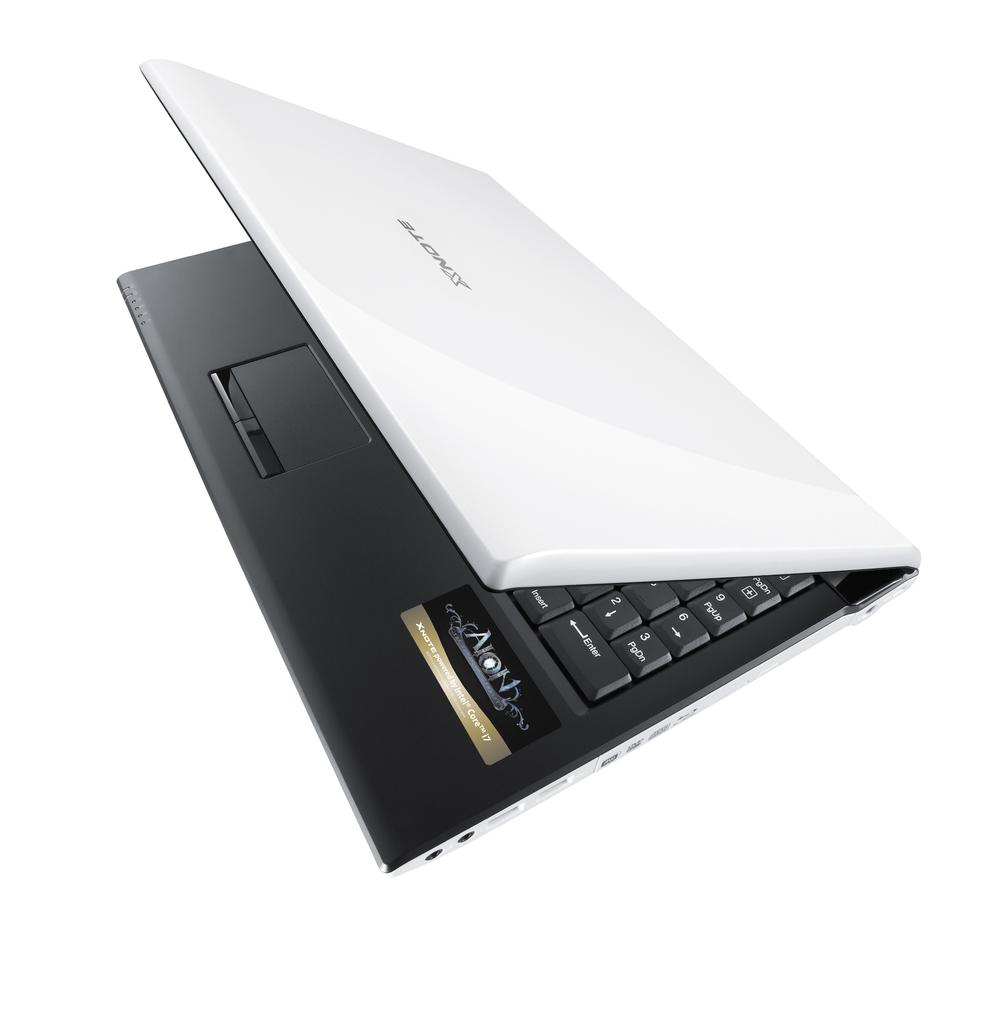Provide a one-sentence caption for the provided image. A laptop computer is halfway open and has the brand name AION on it and it powered by an Intel core processor. 